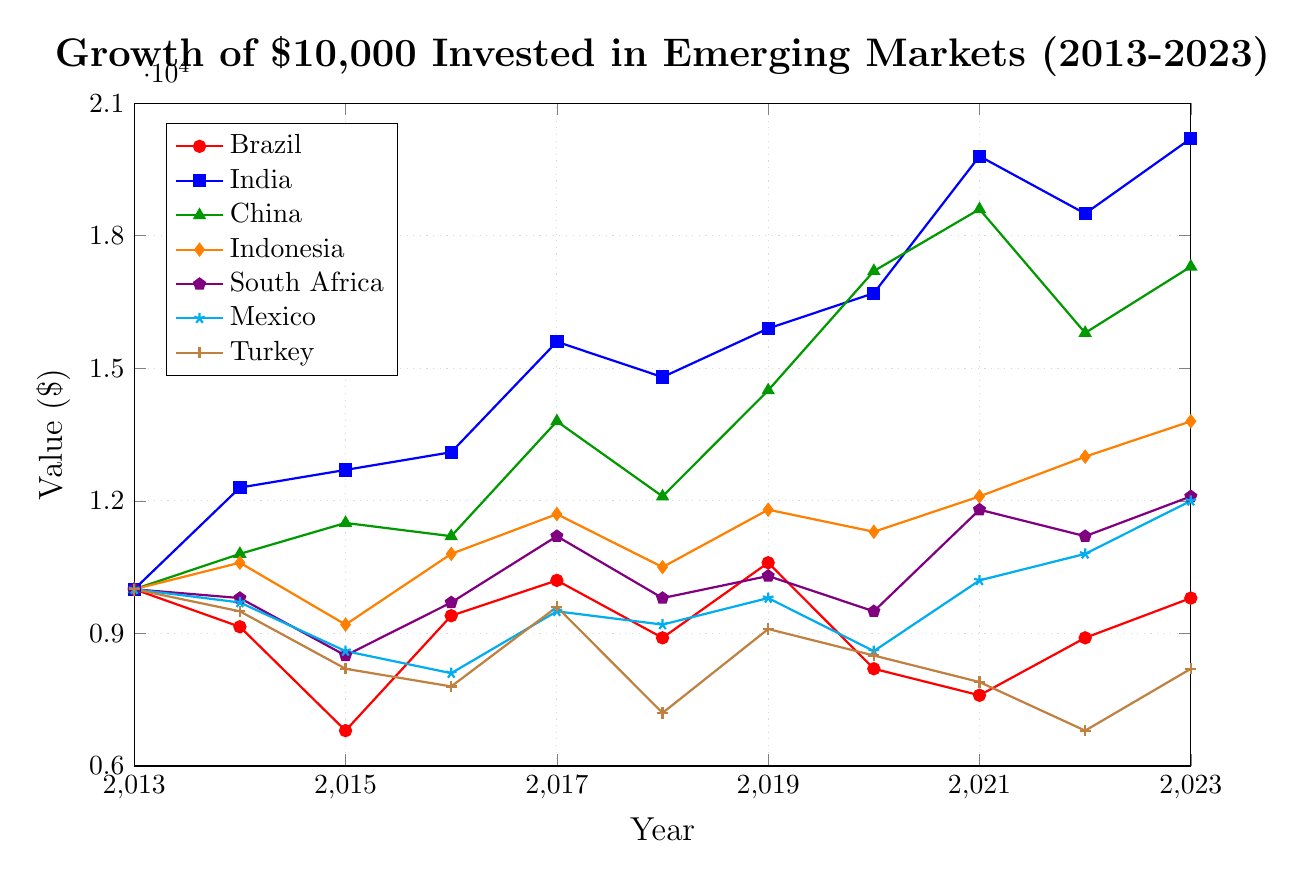What is the value of the investment in India in 2023? Locate the end point for the line labeled "India" on the x-axis for the year 2023, and follow it up to the y-axis. The value reads 20200.
Answer: 20200 Which country saw the highest peak value over the period? Identify the maximum points of all lines on the chart. The line for India reaches the highest at 20200 in the year 2023.
Answer: India What is the difference in investment value between Brazil and China in 2023? Find the values for Brazil and China in 2023. Brazil is at 9800 and China is at 17300. Subtract the value of Brazil from China: 17300 - 9800 = 7500.
Answer: 7500 Which country's investment value decreased the most in 2021 compared to its previous peak? Compare all the peaks before 2021 and drops in 2021. India's value in 2021 (19800) dropped from its previous peak value in 2020 (16700) but peaked in 2021. Brazil's value dropped from 10600 in 2019 to 7600 in 2021, but China also saw a drop from 18600 in 2020 to 15800 in 2022. Brazil has the highest relative decrease.
Answer: Brazil What is the average value of investment in Turkey over the decade? Add up all the yearly values for Turkey from 2013 to 2023 and divide by the number of years. (10000 + 9500 + 8200 + 7800 + 9600 + 7200 + 9100 + 8500 + 7900 + 6800 + 8200) / 11. The total is 92100. The average is 92100 / 11 = 8372.73.
Answer: 8372.73 Which country had the most consistent year-on-year growth? Look at the smoothest line without large dips or spikes. India's line steadily increases every year with only minor dips, indicating the most consistent growth.
Answer: India How many years did South Africa see a decline in investment value from the previous year? Count the number of years where the value declines from the previous year's value for South Africa (2014, 2015, 2018, 2020, 2022). These declines occur in 5 years.
Answer: 5 By what percentage did China's investment value grow from 2013 to 2023? Compute the percentage increase using the formula \( \text{Percentage increase} = \frac{\text{Final value} - \text{Initial value}}{\text{Initial value}} \times 100 \). The initial value in 2013 is 10000 and the final value in 2023 is 17300. The percentage increase is \( \frac{17300 - 10000}{10000} \times 100 \) = 73%.
Answer: 73% In which years did Indonesia outperform the investment value in Mexico? Compare the values of Indonesia and Mexico for each year. Indonesia's value is higher in 2014, 2016, 2017, 2019, 2020, 2021, 2022, and 2023.
Answer: 2014, 2016, 2017, 2019, 2020, 2021, 2022, 2023 What was the value trend for Mexico from 2013 to 2023? For Mexico, read all the values for each year: 10000, 9700, 8600, 8100, 9500, 9200, 9800, 8600, 10200, 10800, 12000. Note the general upward or downward trends. The trend fluctuates but overall shows a general increase from 2016 onwards.
Answer: Fluctuating with a general increase 